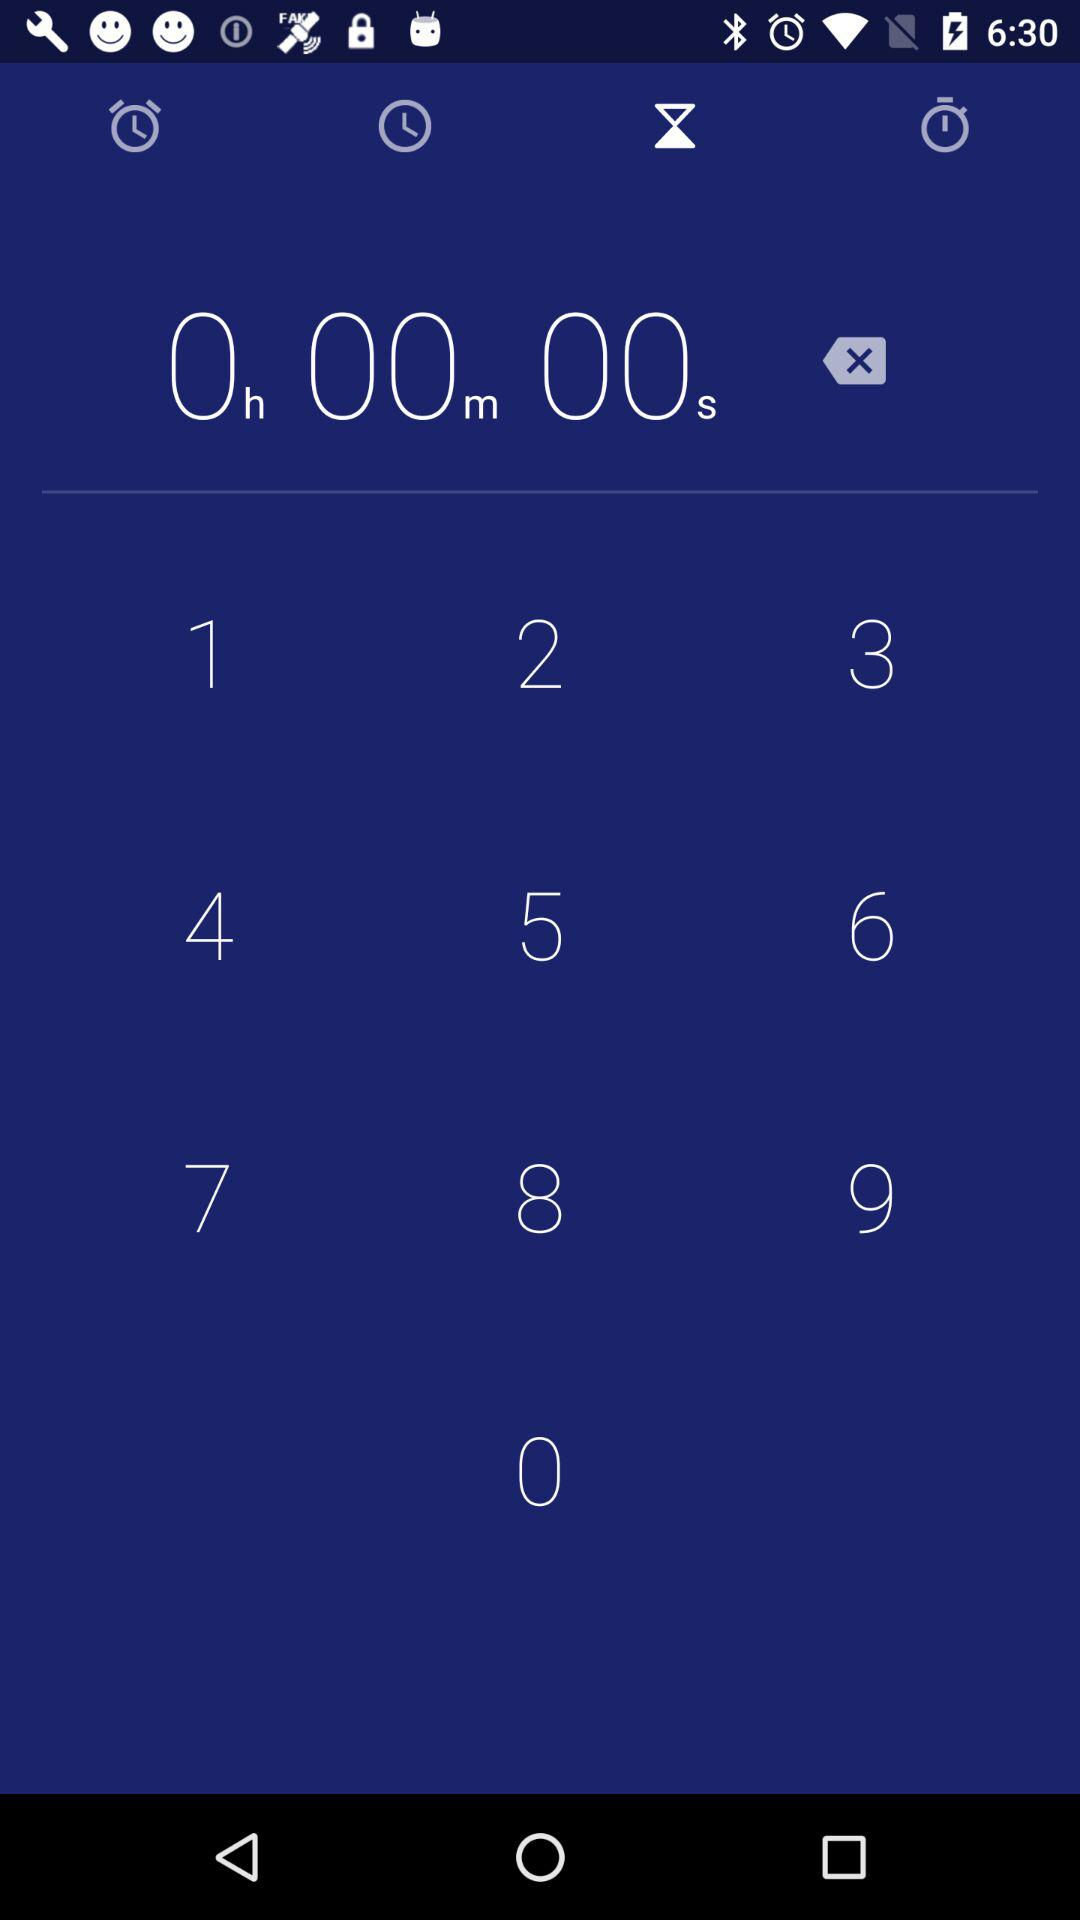What is the name of the application?
When the provided information is insufficient, respond with <no answer>. <no answer> 